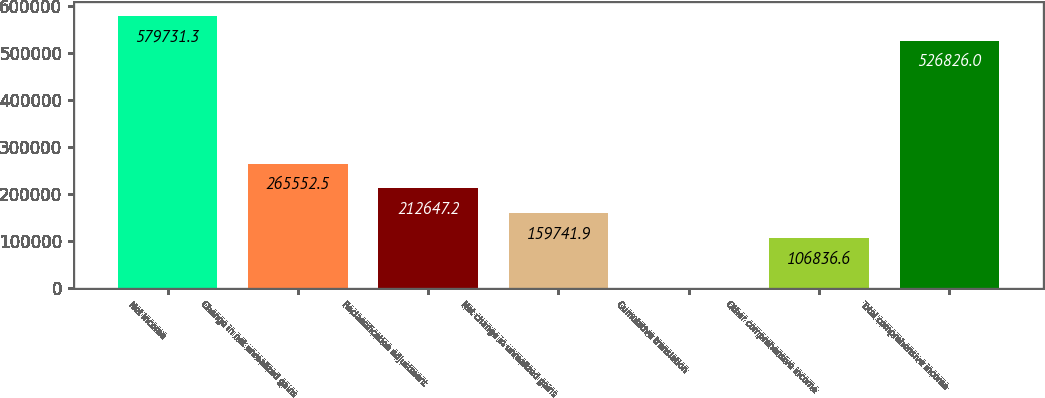Convert chart. <chart><loc_0><loc_0><loc_500><loc_500><bar_chart><fcel>Net income<fcel>Change in net unrealized gains<fcel>Reclassification adjustment<fcel>Net change in unrealized gains<fcel>Cumulative translation<fcel>Other comprehensive income<fcel>Total comprehensive income<nl><fcel>579731<fcel>265552<fcel>212647<fcel>159742<fcel>1026<fcel>106837<fcel>526826<nl></chart> 